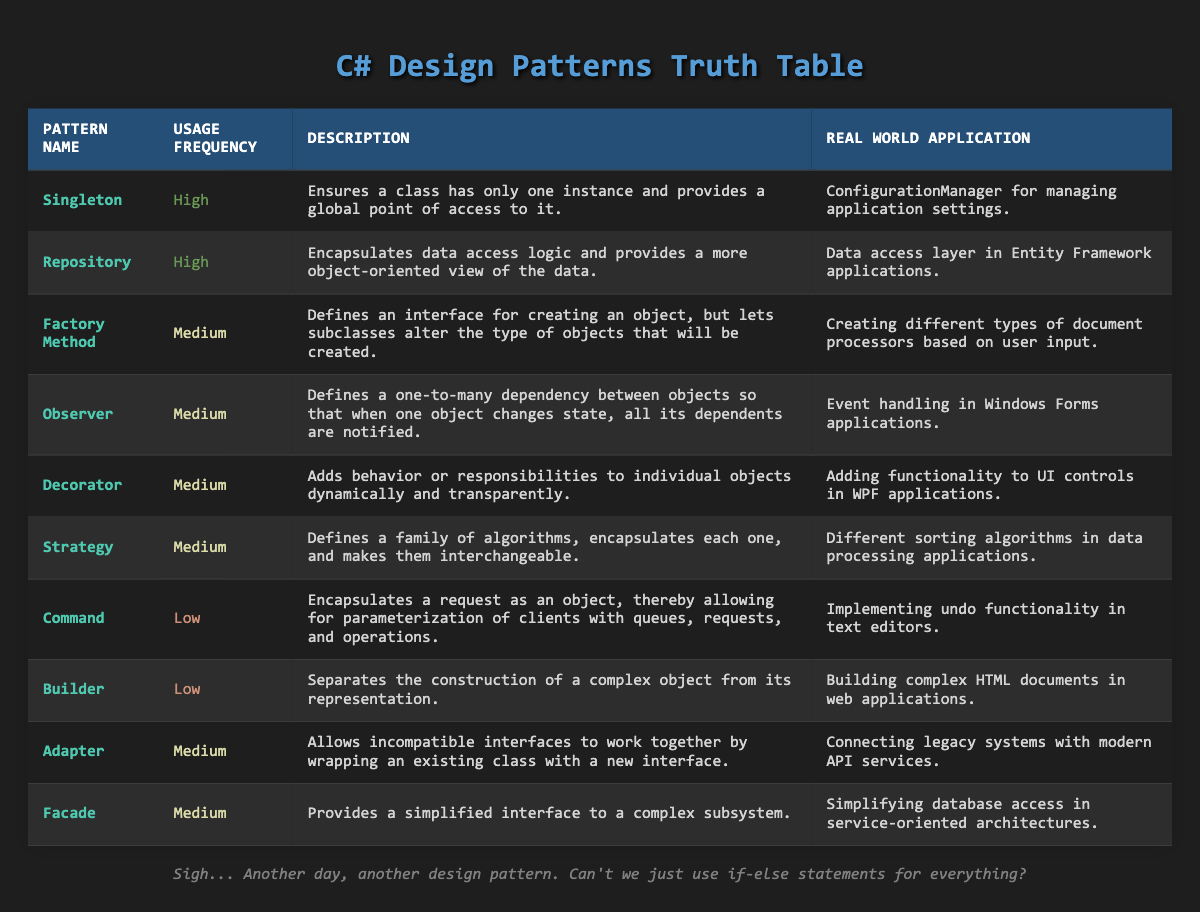What is the usage frequency of the Builder pattern? Referring to the table, the Builder pattern is listed under "Usage Frequency" with the value "Low."
Answer: Low How many design patterns have a High usage frequency? There are 10 patterns listed in total. By reviewing the table, only the Singleton and Repository patterns show a "High" frequency, so there are 2 patterns with high usage.
Answer: 2 What is the description of the Strategy pattern? The Strategy pattern is defined in the table with the following description: "Defines a family of algorithms, encapsulates each one, and makes them interchangeable." This can be directly retrieved from the table.
Answer: Defines a family of algorithms, encapsulates each one, and makes them interchangeable Are there any patterns with a Medium usage frequency that are related to data processing applications? In the table, there are several patterns with "Medium" frequency. Specifically, the Strategy pattern mentions "Different sorting algorithms in data processing applications". Hence, the answer is yes.
Answer: Yes Which pattern has a real-world application involving "text editors"? The table lists the Command pattern with the real-world application: "Implementing undo functionality in text editors." By scanning through the "Real World Application" column, this information can be found.
Answer: Command What is the average usage frequency of patterns associated with UI controls? The relevant patterns listed that are associated with UI controls include Decorator (Medium) and Observer (Medium). Since Medium can be considered a midpoint in a basic scale (High = 3, Medium = 2, Low = 1), we evaluate: (2 + 2) / 2 = 2, which corresponds to medium usage frequency.
Answer: Medium Which pattern is unique for its high frequency of usage compared to others in the table? By evaluating the frequency classification, both the Singleton and Repository patterns have "High" usage frequency. Since there are two at that level, neither is unique.
Answer: None Is there a pattern that connects legacy systems with modern API services? The table identifies the Adapter pattern as having a real-world application of "Connecting legacy systems with modern API services," confirming its existence.
Answer: Yes How many design patterns have a Low usage frequency? Observing the table, the patterns with "Low" frequency are the Command and Builder patterns. Adding these, a total of 2 patterns are categorized as having low frequency.
Answer: 2 